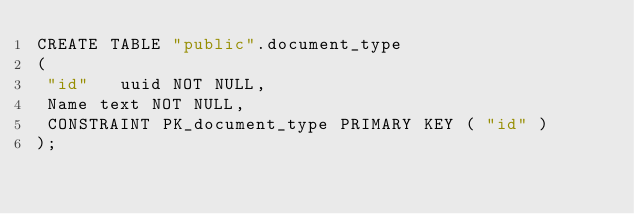Convert code to text. <code><loc_0><loc_0><loc_500><loc_500><_SQL_>CREATE TABLE "public".document_type
(
 "id"   uuid NOT NULL,
 Name text NOT NULL,
 CONSTRAINT PK_document_type PRIMARY KEY ( "id" )
);

</code> 